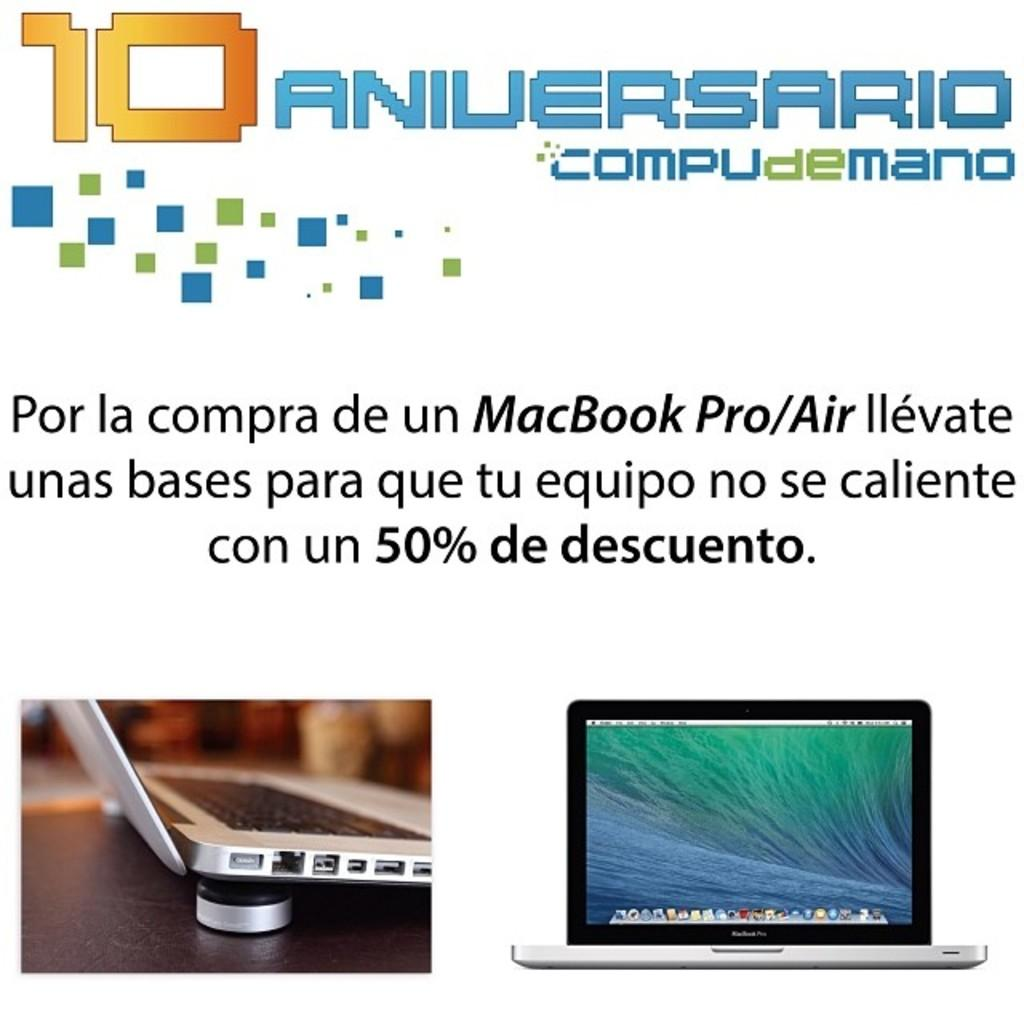<image>
Present a compact description of the photo's key features. An advertisement of a 50% de descuento for the 10 Aniversario for computers. 